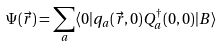Convert formula to latex. <formula><loc_0><loc_0><loc_500><loc_500>\Psi ( \vec { r } ) = \sum _ { a } \langle 0 | q _ { a } ( \vec { r } , 0 ) Q _ { a } ^ { \dag } ( 0 , 0 ) | B \rangle</formula> 